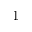<formula> <loc_0><loc_0><loc_500><loc_500>1</formula> 